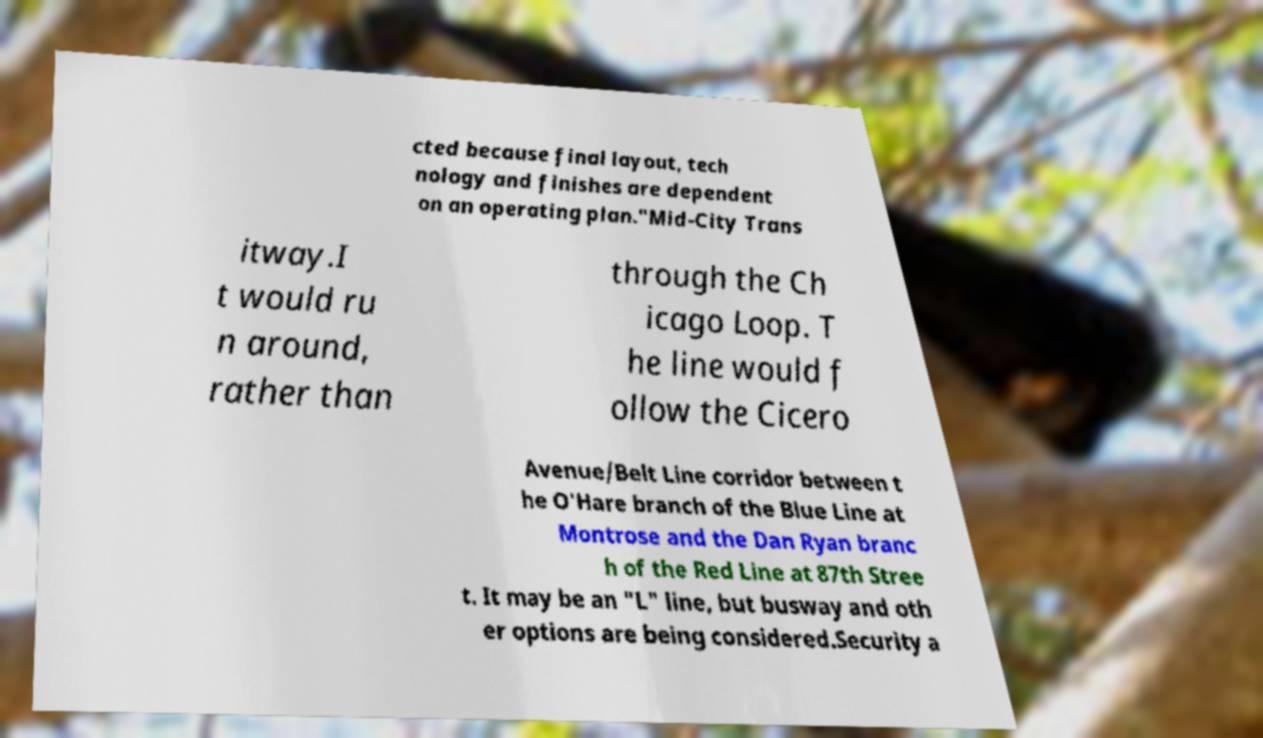What messages or text are displayed in this image? I need them in a readable, typed format. cted because final layout, tech nology and finishes are dependent on an operating plan."Mid-City Trans itway.I t would ru n around, rather than through the Ch icago Loop. T he line would f ollow the Cicero Avenue/Belt Line corridor between t he O'Hare branch of the Blue Line at Montrose and the Dan Ryan branc h of the Red Line at 87th Stree t. It may be an "L" line, but busway and oth er options are being considered.Security a 